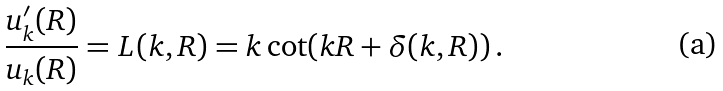Convert formula to latex. <formula><loc_0><loc_0><loc_500><loc_500>\frac { u _ { k } ^ { \prime } ( R ) } { u _ { k } ( R ) } = L ( k , R ) = k \cot ( k R + \delta ( k , R ) ) \, .</formula> 